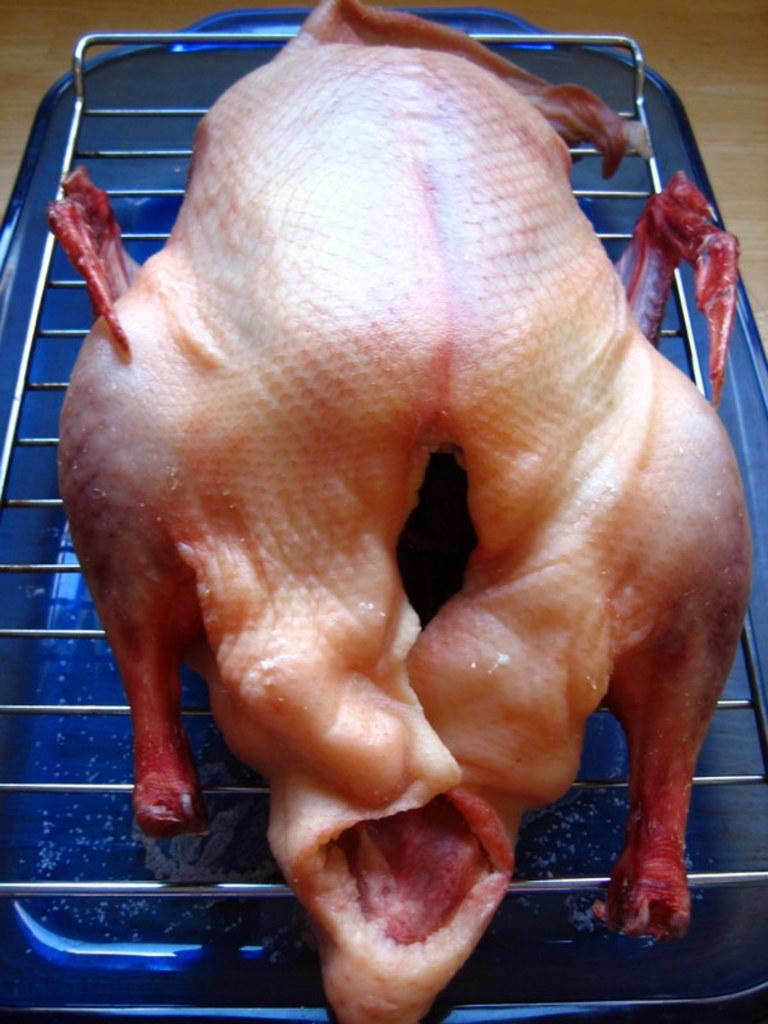What is being cooked on the grill in the image? There is a chicken on the grill in the image. What can be seen at the bottom of the image? There is a blue color tub at the bottom of the image. What type of art is the grandfather creating in the image? There is no grandfather or art present in the image; it only features a chicken on the grill and a blue color tub. 